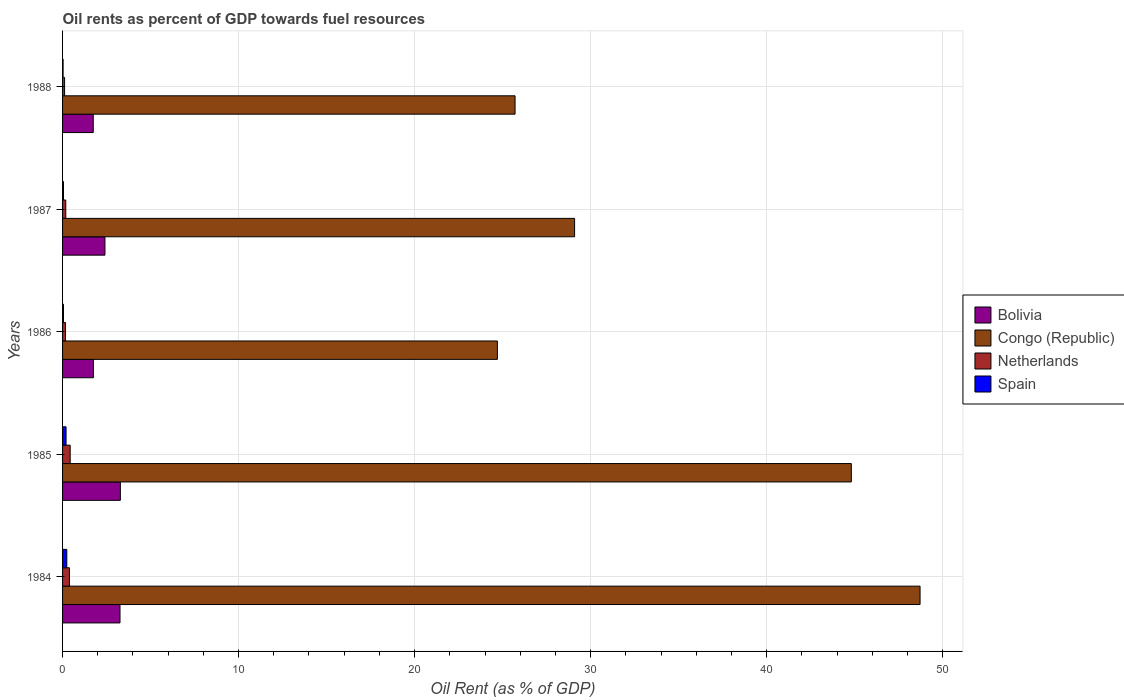How many groups of bars are there?
Your answer should be very brief. 5. Are the number of bars on each tick of the Y-axis equal?
Your answer should be very brief. Yes. How many bars are there on the 5th tick from the top?
Ensure brevity in your answer.  4. What is the oil rent in Spain in 1987?
Provide a short and direct response. 0.05. Across all years, what is the maximum oil rent in Netherlands?
Ensure brevity in your answer.  0.43. Across all years, what is the minimum oil rent in Congo (Republic)?
Offer a terse response. 24.7. In which year was the oil rent in Bolivia maximum?
Make the answer very short. 1985. What is the total oil rent in Spain in the graph?
Ensure brevity in your answer.  0.58. What is the difference between the oil rent in Bolivia in 1985 and that in 1986?
Your answer should be compact. 1.53. What is the difference between the oil rent in Congo (Republic) in 1985 and the oil rent in Netherlands in 1984?
Provide a short and direct response. 44.42. What is the average oil rent in Bolivia per year?
Offer a very short reply. 2.49. In the year 1986, what is the difference between the oil rent in Spain and oil rent in Congo (Republic)?
Ensure brevity in your answer.  -24.65. What is the ratio of the oil rent in Bolivia in 1985 to that in 1988?
Give a very brief answer. 1.88. Is the difference between the oil rent in Spain in 1985 and 1988 greater than the difference between the oil rent in Congo (Republic) in 1985 and 1988?
Your response must be concise. No. What is the difference between the highest and the second highest oil rent in Congo (Republic)?
Make the answer very short. 3.9. What is the difference between the highest and the lowest oil rent in Netherlands?
Offer a very short reply. 0.32. Is the sum of the oil rent in Netherlands in 1984 and 1985 greater than the maximum oil rent in Congo (Republic) across all years?
Your answer should be very brief. No. Is it the case that in every year, the sum of the oil rent in Bolivia and oil rent in Congo (Republic) is greater than the sum of oil rent in Netherlands and oil rent in Spain?
Give a very brief answer. No. What does the 2nd bar from the top in 1984 represents?
Provide a succinct answer. Netherlands. Are all the bars in the graph horizontal?
Provide a short and direct response. Yes. Does the graph contain any zero values?
Offer a terse response. No. Where does the legend appear in the graph?
Offer a very short reply. Center right. What is the title of the graph?
Your answer should be very brief. Oil rents as percent of GDP towards fuel resources. Does "Marshall Islands" appear as one of the legend labels in the graph?
Keep it short and to the point. No. What is the label or title of the X-axis?
Provide a succinct answer. Oil Rent (as % of GDP). What is the label or title of the Y-axis?
Offer a very short reply. Years. What is the Oil Rent (as % of GDP) of Bolivia in 1984?
Your response must be concise. 3.26. What is the Oil Rent (as % of GDP) in Congo (Republic) in 1984?
Ensure brevity in your answer.  48.72. What is the Oil Rent (as % of GDP) of Netherlands in 1984?
Make the answer very short. 0.39. What is the Oil Rent (as % of GDP) in Spain in 1984?
Offer a terse response. 0.24. What is the Oil Rent (as % of GDP) of Bolivia in 1985?
Your answer should be very brief. 3.28. What is the Oil Rent (as % of GDP) of Congo (Republic) in 1985?
Your response must be concise. 44.81. What is the Oil Rent (as % of GDP) in Netherlands in 1985?
Offer a very short reply. 0.43. What is the Oil Rent (as % of GDP) in Spain in 1985?
Offer a terse response. 0.2. What is the Oil Rent (as % of GDP) in Bolivia in 1986?
Your response must be concise. 1.75. What is the Oil Rent (as % of GDP) in Congo (Republic) in 1986?
Ensure brevity in your answer.  24.7. What is the Oil Rent (as % of GDP) of Netherlands in 1986?
Offer a very short reply. 0.17. What is the Oil Rent (as % of GDP) in Spain in 1986?
Ensure brevity in your answer.  0.05. What is the Oil Rent (as % of GDP) in Bolivia in 1987?
Offer a very short reply. 2.41. What is the Oil Rent (as % of GDP) in Congo (Republic) in 1987?
Your answer should be very brief. 29.09. What is the Oil Rent (as % of GDP) in Netherlands in 1987?
Your response must be concise. 0.18. What is the Oil Rent (as % of GDP) of Spain in 1987?
Provide a succinct answer. 0.05. What is the Oil Rent (as % of GDP) in Bolivia in 1988?
Make the answer very short. 1.74. What is the Oil Rent (as % of GDP) of Congo (Republic) in 1988?
Offer a terse response. 25.71. What is the Oil Rent (as % of GDP) of Netherlands in 1988?
Your response must be concise. 0.12. What is the Oil Rent (as % of GDP) in Spain in 1988?
Give a very brief answer. 0.03. Across all years, what is the maximum Oil Rent (as % of GDP) of Bolivia?
Offer a very short reply. 3.28. Across all years, what is the maximum Oil Rent (as % of GDP) of Congo (Republic)?
Offer a terse response. 48.72. Across all years, what is the maximum Oil Rent (as % of GDP) of Netherlands?
Your answer should be very brief. 0.43. Across all years, what is the maximum Oil Rent (as % of GDP) in Spain?
Keep it short and to the point. 0.24. Across all years, what is the minimum Oil Rent (as % of GDP) of Bolivia?
Your response must be concise. 1.74. Across all years, what is the minimum Oil Rent (as % of GDP) in Congo (Republic)?
Provide a short and direct response. 24.7. Across all years, what is the minimum Oil Rent (as % of GDP) of Netherlands?
Your answer should be compact. 0.12. Across all years, what is the minimum Oil Rent (as % of GDP) of Spain?
Offer a terse response. 0.03. What is the total Oil Rent (as % of GDP) of Bolivia in the graph?
Ensure brevity in your answer.  12.45. What is the total Oil Rent (as % of GDP) of Congo (Republic) in the graph?
Keep it short and to the point. 173.03. What is the total Oil Rent (as % of GDP) in Netherlands in the graph?
Your response must be concise. 1.29. What is the total Oil Rent (as % of GDP) of Spain in the graph?
Give a very brief answer. 0.58. What is the difference between the Oil Rent (as % of GDP) of Bolivia in 1984 and that in 1985?
Make the answer very short. -0.02. What is the difference between the Oil Rent (as % of GDP) of Congo (Republic) in 1984 and that in 1985?
Offer a very short reply. 3.9. What is the difference between the Oil Rent (as % of GDP) in Netherlands in 1984 and that in 1985?
Your answer should be very brief. -0.04. What is the difference between the Oil Rent (as % of GDP) in Spain in 1984 and that in 1985?
Ensure brevity in your answer.  0.04. What is the difference between the Oil Rent (as % of GDP) in Bolivia in 1984 and that in 1986?
Your response must be concise. 1.51. What is the difference between the Oil Rent (as % of GDP) of Congo (Republic) in 1984 and that in 1986?
Offer a terse response. 24.01. What is the difference between the Oil Rent (as % of GDP) in Netherlands in 1984 and that in 1986?
Your answer should be very brief. 0.22. What is the difference between the Oil Rent (as % of GDP) in Spain in 1984 and that in 1986?
Offer a very short reply. 0.19. What is the difference between the Oil Rent (as % of GDP) of Bolivia in 1984 and that in 1987?
Your answer should be compact. 0.85. What is the difference between the Oil Rent (as % of GDP) in Congo (Republic) in 1984 and that in 1987?
Provide a short and direct response. 19.63. What is the difference between the Oil Rent (as % of GDP) in Netherlands in 1984 and that in 1987?
Make the answer very short. 0.21. What is the difference between the Oil Rent (as % of GDP) in Spain in 1984 and that in 1987?
Make the answer very short. 0.19. What is the difference between the Oil Rent (as % of GDP) of Bolivia in 1984 and that in 1988?
Offer a terse response. 1.52. What is the difference between the Oil Rent (as % of GDP) in Congo (Republic) in 1984 and that in 1988?
Provide a succinct answer. 23.01. What is the difference between the Oil Rent (as % of GDP) in Netherlands in 1984 and that in 1988?
Your response must be concise. 0.28. What is the difference between the Oil Rent (as % of GDP) in Spain in 1984 and that in 1988?
Make the answer very short. 0.21. What is the difference between the Oil Rent (as % of GDP) of Bolivia in 1985 and that in 1986?
Offer a terse response. 1.53. What is the difference between the Oil Rent (as % of GDP) of Congo (Republic) in 1985 and that in 1986?
Ensure brevity in your answer.  20.11. What is the difference between the Oil Rent (as % of GDP) of Netherlands in 1985 and that in 1986?
Your response must be concise. 0.26. What is the difference between the Oil Rent (as % of GDP) of Spain in 1985 and that in 1986?
Make the answer very short. 0.15. What is the difference between the Oil Rent (as % of GDP) in Bolivia in 1985 and that in 1987?
Your response must be concise. 0.87. What is the difference between the Oil Rent (as % of GDP) of Congo (Republic) in 1985 and that in 1987?
Your answer should be compact. 15.72. What is the difference between the Oil Rent (as % of GDP) of Netherlands in 1985 and that in 1987?
Your response must be concise. 0.25. What is the difference between the Oil Rent (as % of GDP) of Spain in 1985 and that in 1987?
Offer a terse response. 0.15. What is the difference between the Oil Rent (as % of GDP) of Bolivia in 1985 and that in 1988?
Keep it short and to the point. 1.54. What is the difference between the Oil Rent (as % of GDP) of Congo (Republic) in 1985 and that in 1988?
Your answer should be very brief. 19.1. What is the difference between the Oil Rent (as % of GDP) in Netherlands in 1985 and that in 1988?
Offer a very short reply. 0.32. What is the difference between the Oil Rent (as % of GDP) of Spain in 1985 and that in 1988?
Ensure brevity in your answer.  0.17. What is the difference between the Oil Rent (as % of GDP) in Bolivia in 1986 and that in 1987?
Your answer should be compact. -0.66. What is the difference between the Oil Rent (as % of GDP) of Congo (Republic) in 1986 and that in 1987?
Offer a terse response. -4.39. What is the difference between the Oil Rent (as % of GDP) in Netherlands in 1986 and that in 1987?
Your answer should be very brief. -0.01. What is the difference between the Oil Rent (as % of GDP) in Spain in 1986 and that in 1987?
Provide a short and direct response. 0. What is the difference between the Oil Rent (as % of GDP) of Bolivia in 1986 and that in 1988?
Your response must be concise. 0.01. What is the difference between the Oil Rent (as % of GDP) of Congo (Republic) in 1986 and that in 1988?
Your response must be concise. -1. What is the difference between the Oil Rent (as % of GDP) of Netherlands in 1986 and that in 1988?
Your answer should be very brief. 0.05. What is the difference between the Oil Rent (as % of GDP) in Spain in 1986 and that in 1988?
Make the answer very short. 0.02. What is the difference between the Oil Rent (as % of GDP) of Bolivia in 1987 and that in 1988?
Your answer should be very brief. 0.67. What is the difference between the Oil Rent (as % of GDP) in Congo (Republic) in 1987 and that in 1988?
Ensure brevity in your answer.  3.38. What is the difference between the Oil Rent (as % of GDP) of Netherlands in 1987 and that in 1988?
Make the answer very short. 0.07. What is the difference between the Oil Rent (as % of GDP) of Spain in 1987 and that in 1988?
Provide a succinct answer. 0.02. What is the difference between the Oil Rent (as % of GDP) in Bolivia in 1984 and the Oil Rent (as % of GDP) in Congo (Republic) in 1985?
Give a very brief answer. -41.55. What is the difference between the Oil Rent (as % of GDP) in Bolivia in 1984 and the Oil Rent (as % of GDP) in Netherlands in 1985?
Your response must be concise. 2.83. What is the difference between the Oil Rent (as % of GDP) in Bolivia in 1984 and the Oil Rent (as % of GDP) in Spain in 1985?
Provide a succinct answer. 3.06. What is the difference between the Oil Rent (as % of GDP) in Congo (Republic) in 1984 and the Oil Rent (as % of GDP) in Netherlands in 1985?
Offer a very short reply. 48.29. What is the difference between the Oil Rent (as % of GDP) in Congo (Republic) in 1984 and the Oil Rent (as % of GDP) in Spain in 1985?
Your response must be concise. 48.52. What is the difference between the Oil Rent (as % of GDP) of Netherlands in 1984 and the Oil Rent (as % of GDP) of Spain in 1985?
Your answer should be compact. 0.19. What is the difference between the Oil Rent (as % of GDP) in Bolivia in 1984 and the Oil Rent (as % of GDP) in Congo (Republic) in 1986?
Ensure brevity in your answer.  -21.44. What is the difference between the Oil Rent (as % of GDP) of Bolivia in 1984 and the Oil Rent (as % of GDP) of Netherlands in 1986?
Your response must be concise. 3.1. What is the difference between the Oil Rent (as % of GDP) in Bolivia in 1984 and the Oil Rent (as % of GDP) in Spain in 1986?
Provide a succinct answer. 3.21. What is the difference between the Oil Rent (as % of GDP) in Congo (Republic) in 1984 and the Oil Rent (as % of GDP) in Netherlands in 1986?
Make the answer very short. 48.55. What is the difference between the Oil Rent (as % of GDP) of Congo (Republic) in 1984 and the Oil Rent (as % of GDP) of Spain in 1986?
Provide a succinct answer. 48.66. What is the difference between the Oil Rent (as % of GDP) of Netherlands in 1984 and the Oil Rent (as % of GDP) of Spain in 1986?
Your answer should be very brief. 0.34. What is the difference between the Oil Rent (as % of GDP) in Bolivia in 1984 and the Oil Rent (as % of GDP) in Congo (Republic) in 1987?
Make the answer very short. -25.83. What is the difference between the Oil Rent (as % of GDP) in Bolivia in 1984 and the Oil Rent (as % of GDP) in Netherlands in 1987?
Provide a short and direct response. 3.08. What is the difference between the Oil Rent (as % of GDP) in Bolivia in 1984 and the Oil Rent (as % of GDP) in Spain in 1987?
Your answer should be very brief. 3.21. What is the difference between the Oil Rent (as % of GDP) in Congo (Republic) in 1984 and the Oil Rent (as % of GDP) in Netherlands in 1987?
Ensure brevity in your answer.  48.53. What is the difference between the Oil Rent (as % of GDP) of Congo (Republic) in 1984 and the Oil Rent (as % of GDP) of Spain in 1987?
Provide a succinct answer. 48.66. What is the difference between the Oil Rent (as % of GDP) of Netherlands in 1984 and the Oil Rent (as % of GDP) of Spain in 1987?
Your answer should be very brief. 0.34. What is the difference between the Oil Rent (as % of GDP) of Bolivia in 1984 and the Oil Rent (as % of GDP) of Congo (Republic) in 1988?
Ensure brevity in your answer.  -22.44. What is the difference between the Oil Rent (as % of GDP) of Bolivia in 1984 and the Oil Rent (as % of GDP) of Netherlands in 1988?
Provide a short and direct response. 3.15. What is the difference between the Oil Rent (as % of GDP) in Bolivia in 1984 and the Oil Rent (as % of GDP) in Spain in 1988?
Ensure brevity in your answer.  3.23. What is the difference between the Oil Rent (as % of GDP) in Congo (Republic) in 1984 and the Oil Rent (as % of GDP) in Netherlands in 1988?
Make the answer very short. 48.6. What is the difference between the Oil Rent (as % of GDP) in Congo (Republic) in 1984 and the Oil Rent (as % of GDP) in Spain in 1988?
Your response must be concise. 48.69. What is the difference between the Oil Rent (as % of GDP) in Netherlands in 1984 and the Oil Rent (as % of GDP) in Spain in 1988?
Make the answer very short. 0.36. What is the difference between the Oil Rent (as % of GDP) in Bolivia in 1985 and the Oil Rent (as % of GDP) in Congo (Republic) in 1986?
Provide a succinct answer. -21.42. What is the difference between the Oil Rent (as % of GDP) in Bolivia in 1985 and the Oil Rent (as % of GDP) in Netherlands in 1986?
Offer a terse response. 3.12. What is the difference between the Oil Rent (as % of GDP) in Bolivia in 1985 and the Oil Rent (as % of GDP) in Spain in 1986?
Your response must be concise. 3.23. What is the difference between the Oil Rent (as % of GDP) of Congo (Republic) in 1985 and the Oil Rent (as % of GDP) of Netherlands in 1986?
Ensure brevity in your answer.  44.64. What is the difference between the Oil Rent (as % of GDP) of Congo (Republic) in 1985 and the Oil Rent (as % of GDP) of Spain in 1986?
Your answer should be compact. 44.76. What is the difference between the Oil Rent (as % of GDP) in Netherlands in 1985 and the Oil Rent (as % of GDP) in Spain in 1986?
Your answer should be compact. 0.38. What is the difference between the Oil Rent (as % of GDP) in Bolivia in 1985 and the Oil Rent (as % of GDP) in Congo (Republic) in 1987?
Your answer should be compact. -25.81. What is the difference between the Oil Rent (as % of GDP) in Bolivia in 1985 and the Oil Rent (as % of GDP) in Netherlands in 1987?
Offer a very short reply. 3.1. What is the difference between the Oil Rent (as % of GDP) in Bolivia in 1985 and the Oil Rent (as % of GDP) in Spain in 1987?
Your answer should be compact. 3.23. What is the difference between the Oil Rent (as % of GDP) in Congo (Republic) in 1985 and the Oil Rent (as % of GDP) in Netherlands in 1987?
Offer a terse response. 44.63. What is the difference between the Oil Rent (as % of GDP) in Congo (Republic) in 1985 and the Oil Rent (as % of GDP) in Spain in 1987?
Make the answer very short. 44.76. What is the difference between the Oil Rent (as % of GDP) in Netherlands in 1985 and the Oil Rent (as % of GDP) in Spain in 1987?
Offer a very short reply. 0.38. What is the difference between the Oil Rent (as % of GDP) in Bolivia in 1985 and the Oil Rent (as % of GDP) in Congo (Republic) in 1988?
Keep it short and to the point. -22.42. What is the difference between the Oil Rent (as % of GDP) in Bolivia in 1985 and the Oil Rent (as % of GDP) in Netherlands in 1988?
Provide a succinct answer. 3.17. What is the difference between the Oil Rent (as % of GDP) in Bolivia in 1985 and the Oil Rent (as % of GDP) in Spain in 1988?
Your answer should be very brief. 3.25. What is the difference between the Oil Rent (as % of GDP) of Congo (Republic) in 1985 and the Oil Rent (as % of GDP) of Netherlands in 1988?
Keep it short and to the point. 44.7. What is the difference between the Oil Rent (as % of GDP) of Congo (Republic) in 1985 and the Oil Rent (as % of GDP) of Spain in 1988?
Provide a succinct answer. 44.78. What is the difference between the Oil Rent (as % of GDP) in Netherlands in 1985 and the Oil Rent (as % of GDP) in Spain in 1988?
Your response must be concise. 0.4. What is the difference between the Oil Rent (as % of GDP) of Bolivia in 1986 and the Oil Rent (as % of GDP) of Congo (Republic) in 1987?
Provide a short and direct response. -27.34. What is the difference between the Oil Rent (as % of GDP) in Bolivia in 1986 and the Oil Rent (as % of GDP) in Netherlands in 1987?
Your answer should be very brief. 1.57. What is the difference between the Oil Rent (as % of GDP) of Bolivia in 1986 and the Oil Rent (as % of GDP) of Spain in 1987?
Your response must be concise. 1.7. What is the difference between the Oil Rent (as % of GDP) of Congo (Republic) in 1986 and the Oil Rent (as % of GDP) of Netherlands in 1987?
Offer a very short reply. 24.52. What is the difference between the Oil Rent (as % of GDP) of Congo (Republic) in 1986 and the Oil Rent (as % of GDP) of Spain in 1987?
Offer a very short reply. 24.65. What is the difference between the Oil Rent (as % of GDP) in Netherlands in 1986 and the Oil Rent (as % of GDP) in Spain in 1987?
Make the answer very short. 0.11. What is the difference between the Oil Rent (as % of GDP) of Bolivia in 1986 and the Oil Rent (as % of GDP) of Congo (Republic) in 1988?
Your answer should be compact. -23.96. What is the difference between the Oil Rent (as % of GDP) of Bolivia in 1986 and the Oil Rent (as % of GDP) of Netherlands in 1988?
Your answer should be compact. 1.64. What is the difference between the Oil Rent (as % of GDP) of Bolivia in 1986 and the Oil Rent (as % of GDP) of Spain in 1988?
Make the answer very short. 1.72. What is the difference between the Oil Rent (as % of GDP) in Congo (Republic) in 1986 and the Oil Rent (as % of GDP) in Netherlands in 1988?
Provide a short and direct response. 24.59. What is the difference between the Oil Rent (as % of GDP) in Congo (Republic) in 1986 and the Oil Rent (as % of GDP) in Spain in 1988?
Provide a short and direct response. 24.67. What is the difference between the Oil Rent (as % of GDP) in Netherlands in 1986 and the Oil Rent (as % of GDP) in Spain in 1988?
Your response must be concise. 0.14. What is the difference between the Oil Rent (as % of GDP) in Bolivia in 1987 and the Oil Rent (as % of GDP) in Congo (Republic) in 1988?
Keep it short and to the point. -23.3. What is the difference between the Oil Rent (as % of GDP) of Bolivia in 1987 and the Oil Rent (as % of GDP) of Netherlands in 1988?
Offer a very short reply. 2.29. What is the difference between the Oil Rent (as % of GDP) of Bolivia in 1987 and the Oil Rent (as % of GDP) of Spain in 1988?
Make the answer very short. 2.38. What is the difference between the Oil Rent (as % of GDP) of Congo (Republic) in 1987 and the Oil Rent (as % of GDP) of Netherlands in 1988?
Offer a very short reply. 28.97. What is the difference between the Oil Rent (as % of GDP) in Congo (Republic) in 1987 and the Oil Rent (as % of GDP) in Spain in 1988?
Offer a very short reply. 29.06. What is the difference between the Oil Rent (as % of GDP) of Netherlands in 1987 and the Oil Rent (as % of GDP) of Spain in 1988?
Give a very brief answer. 0.15. What is the average Oil Rent (as % of GDP) in Bolivia per year?
Ensure brevity in your answer.  2.49. What is the average Oil Rent (as % of GDP) of Congo (Republic) per year?
Give a very brief answer. 34.61. What is the average Oil Rent (as % of GDP) in Netherlands per year?
Offer a very short reply. 0.26. What is the average Oil Rent (as % of GDP) in Spain per year?
Your answer should be very brief. 0.12. In the year 1984, what is the difference between the Oil Rent (as % of GDP) of Bolivia and Oil Rent (as % of GDP) of Congo (Republic)?
Offer a very short reply. -45.45. In the year 1984, what is the difference between the Oil Rent (as % of GDP) of Bolivia and Oil Rent (as % of GDP) of Netherlands?
Offer a very short reply. 2.87. In the year 1984, what is the difference between the Oil Rent (as % of GDP) in Bolivia and Oil Rent (as % of GDP) in Spain?
Keep it short and to the point. 3.02. In the year 1984, what is the difference between the Oil Rent (as % of GDP) in Congo (Republic) and Oil Rent (as % of GDP) in Netherlands?
Give a very brief answer. 48.33. In the year 1984, what is the difference between the Oil Rent (as % of GDP) in Congo (Republic) and Oil Rent (as % of GDP) in Spain?
Offer a terse response. 48.48. In the year 1984, what is the difference between the Oil Rent (as % of GDP) in Netherlands and Oil Rent (as % of GDP) in Spain?
Provide a succinct answer. 0.15. In the year 1985, what is the difference between the Oil Rent (as % of GDP) of Bolivia and Oil Rent (as % of GDP) of Congo (Republic)?
Offer a terse response. -41.53. In the year 1985, what is the difference between the Oil Rent (as % of GDP) in Bolivia and Oil Rent (as % of GDP) in Netherlands?
Your response must be concise. 2.85. In the year 1985, what is the difference between the Oil Rent (as % of GDP) of Bolivia and Oil Rent (as % of GDP) of Spain?
Your answer should be very brief. 3.08. In the year 1985, what is the difference between the Oil Rent (as % of GDP) of Congo (Republic) and Oil Rent (as % of GDP) of Netherlands?
Offer a very short reply. 44.38. In the year 1985, what is the difference between the Oil Rent (as % of GDP) of Congo (Republic) and Oil Rent (as % of GDP) of Spain?
Your answer should be compact. 44.61. In the year 1985, what is the difference between the Oil Rent (as % of GDP) of Netherlands and Oil Rent (as % of GDP) of Spain?
Keep it short and to the point. 0.23. In the year 1986, what is the difference between the Oil Rent (as % of GDP) in Bolivia and Oil Rent (as % of GDP) in Congo (Republic)?
Offer a very short reply. -22.95. In the year 1986, what is the difference between the Oil Rent (as % of GDP) in Bolivia and Oil Rent (as % of GDP) in Netherlands?
Make the answer very short. 1.58. In the year 1986, what is the difference between the Oil Rent (as % of GDP) of Bolivia and Oil Rent (as % of GDP) of Spain?
Give a very brief answer. 1.7. In the year 1986, what is the difference between the Oil Rent (as % of GDP) of Congo (Republic) and Oil Rent (as % of GDP) of Netherlands?
Your answer should be compact. 24.54. In the year 1986, what is the difference between the Oil Rent (as % of GDP) in Congo (Republic) and Oil Rent (as % of GDP) in Spain?
Provide a short and direct response. 24.65. In the year 1986, what is the difference between the Oil Rent (as % of GDP) in Netherlands and Oil Rent (as % of GDP) in Spain?
Offer a very short reply. 0.11. In the year 1987, what is the difference between the Oil Rent (as % of GDP) of Bolivia and Oil Rent (as % of GDP) of Congo (Republic)?
Make the answer very short. -26.68. In the year 1987, what is the difference between the Oil Rent (as % of GDP) in Bolivia and Oil Rent (as % of GDP) in Netherlands?
Provide a short and direct response. 2.23. In the year 1987, what is the difference between the Oil Rent (as % of GDP) of Bolivia and Oil Rent (as % of GDP) of Spain?
Keep it short and to the point. 2.36. In the year 1987, what is the difference between the Oil Rent (as % of GDP) in Congo (Republic) and Oil Rent (as % of GDP) in Netherlands?
Make the answer very short. 28.91. In the year 1987, what is the difference between the Oil Rent (as % of GDP) of Congo (Republic) and Oil Rent (as % of GDP) of Spain?
Keep it short and to the point. 29.04. In the year 1987, what is the difference between the Oil Rent (as % of GDP) of Netherlands and Oil Rent (as % of GDP) of Spain?
Provide a short and direct response. 0.13. In the year 1988, what is the difference between the Oil Rent (as % of GDP) in Bolivia and Oil Rent (as % of GDP) in Congo (Republic)?
Your answer should be compact. -23.96. In the year 1988, what is the difference between the Oil Rent (as % of GDP) in Bolivia and Oil Rent (as % of GDP) in Netherlands?
Make the answer very short. 1.63. In the year 1988, what is the difference between the Oil Rent (as % of GDP) in Bolivia and Oil Rent (as % of GDP) in Spain?
Provide a succinct answer. 1.71. In the year 1988, what is the difference between the Oil Rent (as % of GDP) of Congo (Republic) and Oil Rent (as % of GDP) of Netherlands?
Make the answer very short. 25.59. In the year 1988, what is the difference between the Oil Rent (as % of GDP) in Congo (Republic) and Oil Rent (as % of GDP) in Spain?
Make the answer very short. 25.68. In the year 1988, what is the difference between the Oil Rent (as % of GDP) in Netherlands and Oil Rent (as % of GDP) in Spain?
Your answer should be compact. 0.09. What is the ratio of the Oil Rent (as % of GDP) in Bolivia in 1984 to that in 1985?
Offer a terse response. 0.99. What is the ratio of the Oil Rent (as % of GDP) of Congo (Republic) in 1984 to that in 1985?
Offer a very short reply. 1.09. What is the ratio of the Oil Rent (as % of GDP) of Netherlands in 1984 to that in 1985?
Your answer should be very brief. 0.91. What is the ratio of the Oil Rent (as % of GDP) in Spain in 1984 to that in 1985?
Make the answer very short. 1.21. What is the ratio of the Oil Rent (as % of GDP) in Bolivia in 1984 to that in 1986?
Ensure brevity in your answer.  1.86. What is the ratio of the Oil Rent (as % of GDP) of Congo (Republic) in 1984 to that in 1986?
Offer a terse response. 1.97. What is the ratio of the Oil Rent (as % of GDP) in Netherlands in 1984 to that in 1986?
Your answer should be compact. 2.34. What is the ratio of the Oil Rent (as % of GDP) of Spain in 1984 to that in 1986?
Your answer should be compact. 4.54. What is the ratio of the Oil Rent (as % of GDP) in Bolivia in 1984 to that in 1987?
Offer a terse response. 1.35. What is the ratio of the Oil Rent (as % of GDP) of Congo (Republic) in 1984 to that in 1987?
Your response must be concise. 1.67. What is the ratio of the Oil Rent (as % of GDP) of Netherlands in 1984 to that in 1987?
Give a very brief answer. 2.15. What is the ratio of the Oil Rent (as % of GDP) in Spain in 1984 to that in 1987?
Your answer should be very brief. 4.56. What is the ratio of the Oil Rent (as % of GDP) in Bolivia in 1984 to that in 1988?
Offer a terse response. 1.87. What is the ratio of the Oil Rent (as % of GDP) in Congo (Republic) in 1984 to that in 1988?
Keep it short and to the point. 1.9. What is the ratio of the Oil Rent (as % of GDP) of Netherlands in 1984 to that in 1988?
Your response must be concise. 3.38. What is the ratio of the Oil Rent (as % of GDP) in Spain in 1984 to that in 1988?
Your answer should be compact. 8.01. What is the ratio of the Oil Rent (as % of GDP) of Bolivia in 1985 to that in 1986?
Your answer should be compact. 1.87. What is the ratio of the Oil Rent (as % of GDP) in Congo (Republic) in 1985 to that in 1986?
Provide a short and direct response. 1.81. What is the ratio of the Oil Rent (as % of GDP) of Netherlands in 1985 to that in 1986?
Provide a short and direct response. 2.58. What is the ratio of the Oil Rent (as % of GDP) in Spain in 1985 to that in 1986?
Provide a succinct answer. 3.74. What is the ratio of the Oil Rent (as % of GDP) in Bolivia in 1985 to that in 1987?
Provide a succinct answer. 1.36. What is the ratio of the Oil Rent (as % of GDP) in Congo (Republic) in 1985 to that in 1987?
Offer a terse response. 1.54. What is the ratio of the Oil Rent (as % of GDP) of Netherlands in 1985 to that in 1987?
Your answer should be compact. 2.37. What is the ratio of the Oil Rent (as % of GDP) of Spain in 1985 to that in 1987?
Ensure brevity in your answer.  3.76. What is the ratio of the Oil Rent (as % of GDP) in Bolivia in 1985 to that in 1988?
Your answer should be compact. 1.88. What is the ratio of the Oil Rent (as % of GDP) in Congo (Republic) in 1985 to that in 1988?
Make the answer very short. 1.74. What is the ratio of the Oil Rent (as % of GDP) in Netherlands in 1985 to that in 1988?
Offer a terse response. 3.73. What is the ratio of the Oil Rent (as % of GDP) in Spain in 1985 to that in 1988?
Provide a succinct answer. 6.6. What is the ratio of the Oil Rent (as % of GDP) of Bolivia in 1986 to that in 1987?
Your response must be concise. 0.73. What is the ratio of the Oil Rent (as % of GDP) in Congo (Republic) in 1986 to that in 1987?
Your answer should be very brief. 0.85. What is the ratio of the Oil Rent (as % of GDP) of Netherlands in 1986 to that in 1987?
Your response must be concise. 0.92. What is the ratio of the Oil Rent (as % of GDP) of Bolivia in 1986 to that in 1988?
Provide a succinct answer. 1.01. What is the ratio of the Oil Rent (as % of GDP) of Congo (Republic) in 1986 to that in 1988?
Your answer should be very brief. 0.96. What is the ratio of the Oil Rent (as % of GDP) of Netherlands in 1986 to that in 1988?
Keep it short and to the point. 1.45. What is the ratio of the Oil Rent (as % of GDP) in Spain in 1986 to that in 1988?
Make the answer very short. 1.77. What is the ratio of the Oil Rent (as % of GDP) of Bolivia in 1987 to that in 1988?
Give a very brief answer. 1.38. What is the ratio of the Oil Rent (as % of GDP) of Congo (Republic) in 1987 to that in 1988?
Your answer should be very brief. 1.13. What is the ratio of the Oil Rent (as % of GDP) in Netherlands in 1987 to that in 1988?
Make the answer very short. 1.58. What is the ratio of the Oil Rent (as % of GDP) of Spain in 1987 to that in 1988?
Your answer should be compact. 1.76. What is the difference between the highest and the second highest Oil Rent (as % of GDP) of Bolivia?
Keep it short and to the point. 0.02. What is the difference between the highest and the second highest Oil Rent (as % of GDP) in Congo (Republic)?
Ensure brevity in your answer.  3.9. What is the difference between the highest and the second highest Oil Rent (as % of GDP) of Netherlands?
Give a very brief answer. 0.04. What is the difference between the highest and the second highest Oil Rent (as % of GDP) of Spain?
Ensure brevity in your answer.  0.04. What is the difference between the highest and the lowest Oil Rent (as % of GDP) in Bolivia?
Keep it short and to the point. 1.54. What is the difference between the highest and the lowest Oil Rent (as % of GDP) of Congo (Republic)?
Your answer should be very brief. 24.01. What is the difference between the highest and the lowest Oil Rent (as % of GDP) of Netherlands?
Provide a succinct answer. 0.32. What is the difference between the highest and the lowest Oil Rent (as % of GDP) of Spain?
Ensure brevity in your answer.  0.21. 